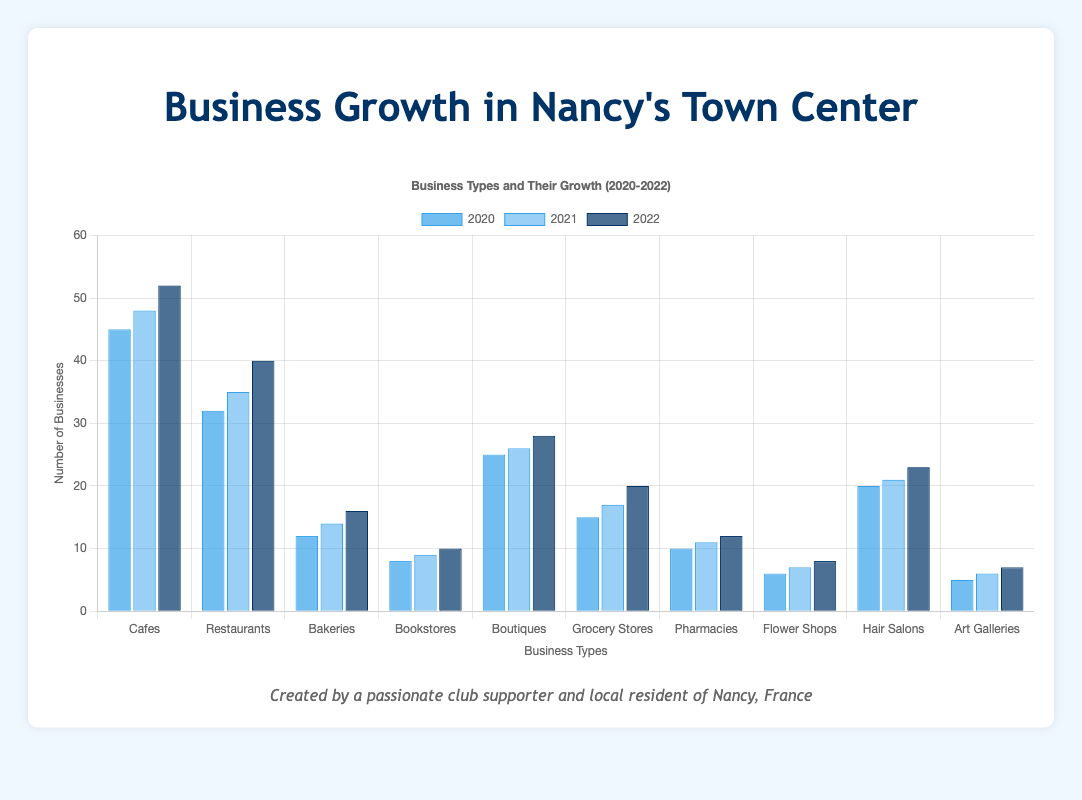Which business type had the highest growth from 2020 to 2022? To find the business type with the highest growth, subtract the 2020 count from the 2022 count for each type: Cafes (52-45=7), Restaurants (40-32=8), Bakeries (16-12=4), Bookstores (10-8=2), Boutiques (28-25=3), Grocery Stores (20-15=5), Pharmacies (12-10=2), Flower Shops (8-6=2), Hair Salons (23-20=3), Art Galleries (7-5=2). Restaurants had the highest growth of 8.
Answer: Restaurants How many cafes were added between 2020 and 2022? To find the increase in the number of cafes, subtract the 2020 count from the 2022 count: 52-45.
Answer: 7 Which business type had the smallest growth from 2020 to 2022? Subtract the 2020 count from the 2022 count for each type: Cafes (7), Restaurants (8), Bakeries (4), Bookstores (2), Boutiques (3), Grocery Stores (5), Pharmacies (2), Flower Shops (2), Hair Salons (3), Art Galleries (2). Bookstores, Pharmacies, Flower Shops, and Art Galleries all had the smallest growth of 2.
Answer: Bookstores, Pharmacies, Flower Shops, and Art Galleries How many more restaurants were there in 2022 compared to bakeries in 2022? Subtract the number of bakeries from the number of restaurants in 2022: 40-16.
Answer: 24 What is the total number of businesses (of all types) in 2021? Sum the counts of all business types for 2021: 48 (Cafes) + 35 (Restaurants) + 14 (Bakeries) + 9 (Bookstores) + 26 (Boutiques) + 17 (Grocery Stores) + 11 (Pharmacies) + 7 (Flower Shops) + 21 (Hair Salons) + 6 (Art Galleries) = 194.
Answer: 194 Which year saw the highest number of grocery stores? Compare the counts of grocery stores across all three years: 2020 (15), 2021 (17), and 2022 (20). 2022 had the highest number.
Answer: 2022 By how much did the number of bookstores increase from 2020 to 2021? Subtract the 2020 count from the 2021 count: 9-8.
Answer: 1 Which business type showed continuous growth each year from 2020 to 2022? Check if each business type's count continuously increased over the years: Cafes (45, 48, 52), Restaurants (32, 35, 40), Bakeries (12, 14, 16), Bookstores (8, 9, 10), Boutiques (25, 26, 28), Grocery Stores (15, 17, 20), Pharmacies (10, 11, 12), Flower Shops (6, 7, 8), Hair Salons (20, 21, 23), Art Galleries (5, 6, 7). All listed business types showed continuous growth.
Answer: All listed business types What is the percentage growth in the number of pharmacies from 2020 to 2022? Calculate the percentage growth: ((12-10)/10) * 100 = 20%.
Answer: 20% How many businesses were added in total between 2020 and 2022? Calculate the total number of businesses in 2022 and 2020, then find the difference: 2022 total = 52 (Cafes) + 40 (Restaurants) + 16 (Bakeries) + 10 (Bookstores) + 28 (Boutiques) + 20 (Grocery Stores) + 12 (Pharmacies) + 8 (Flower Shops) + 23 (Hair Salons) + 7 (Art Galleries) = 216. 2020 total = 45 (Cafes) + 32 (Restaurants) + 12 (Bakeries) + 8 (Bookstores) + 25 (Boutiques) + 15 (Grocery Stores) + 10 (Pharmacies) + 6 (Flower Shops) + 20 (Hair Salons) + 5 (Art Galleries) = 178. So, 216 - 178 = 38.
Answer: 38 